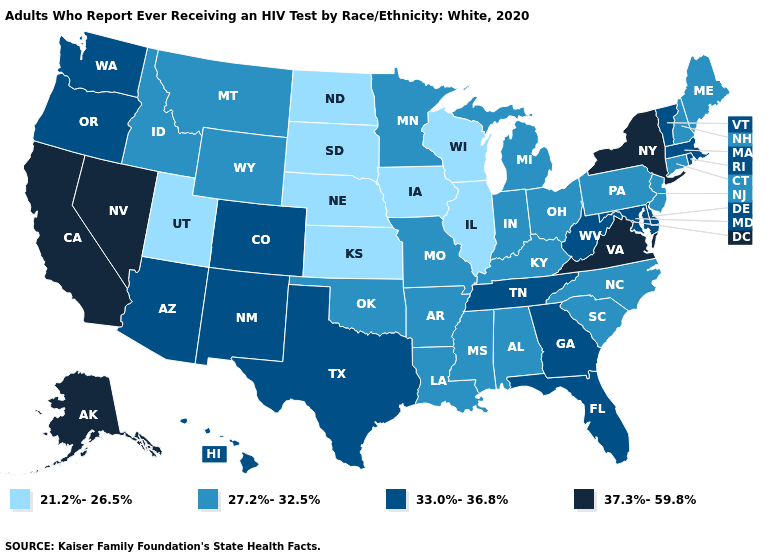What is the value of Georgia?
Answer briefly. 33.0%-36.8%. Name the states that have a value in the range 37.3%-59.8%?
Keep it brief. Alaska, California, Nevada, New York, Virginia. What is the value of New Hampshire?
Give a very brief answer. 27.2%-32.5%. Among the states that border Iowa , which have the highest value?
Answer briefly. Minnesota, Missouri. Does Hawaii have a higher value than South Carolina?
Quick response, please. Yes. Does North Carolina have the same value as Vermont?
Answer briefly. No. Does Montana have the lowest value in the West?
Keep it brief. No. What is the value of Connecticut?
Quick response, please. 27.2%-32.5%. Name the states that have a value in the range 33.0%-36.8%?
Concise answer only. Arizona, Colorado, Delaware, Florida, Georgia, Hawaii, Maryland, Massachusetts, New Mexico, Oregon, Rhode Island, Tennessee, Texas, Vermont, Washington, West Virginia. Name the states that have a value in the range 37.3%-59.8%?
Be succinct. Alaska, California, Nevada, New York, Virginia. Among the states that border New Jersey , does New York have the highest value?
Quick response, please. Yes. Does Maryland have the same value as Ohio?
Write a very short answer. No. How many symbols are there in the legend?
Give a very brief answer. 4. 